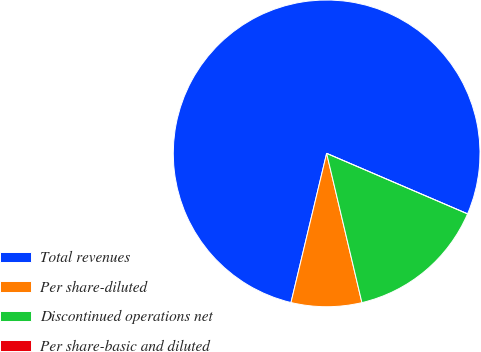<chart> <loc_0><loc_0><loc_500><loc_500><pie_chart><fcel>Total revenues<fcel>Per share-diluted<fcel>Discontinued operations net<fcel>Per share-basic and diluted<nl><fcel>77.72%<fcel>7.43%<fcel>14.85%<fcel>0.0%<nl></chart> 